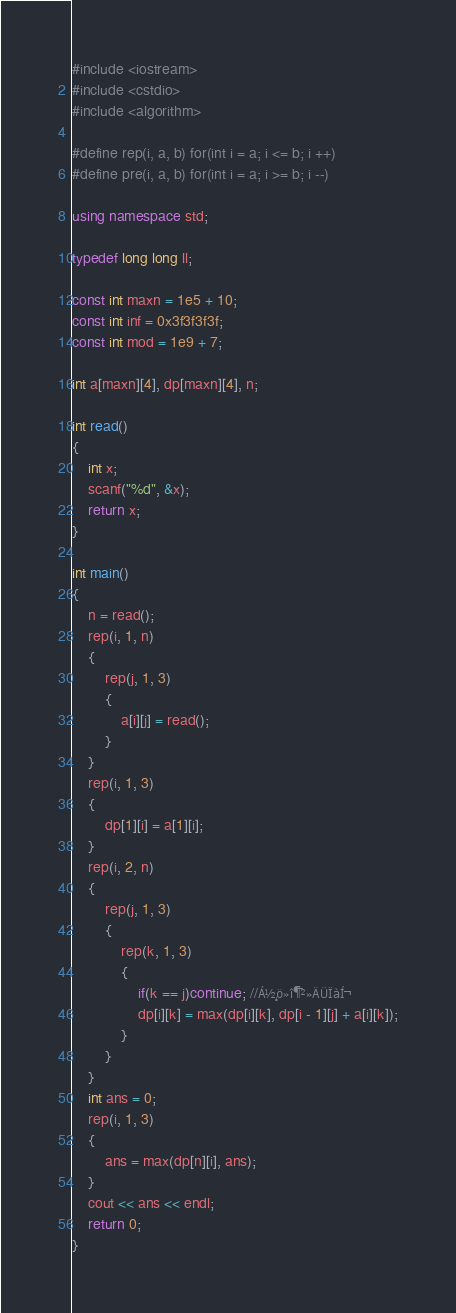<code> <loc_0><loc_0><loc_500><loc_500><_C++_>#include <iostream>
#include <cstdio>
#include <algorithm>

#define rep(i, a, b) for(int i = a; i <= b; i ++)
#define pre(i, a, b) for(int i = a; i >= b; i --)

using namespace std;

typedef long long ll;

const int maxn = 1e5 + 10;
const int inf = 0x3f3f3f3f;
const int mod = 1e9 + 7;

int a[maxn][4], dp[maxn][4], n;

int read()
{
	int x;
	scanf("%d", &x);
	return x;
}

int main()
{
	n = read();
	rep(i, 1, n)
	{
		rep(j, 1, 3)
		{
			a[i][j] = read();
		}
	}
	rep(i, 1, 3)
	{
		dp[1][i] = a[1][i];
	}
	rep(i, 2, n)
	{
		rep(j, 1, 3)
		{
			rep(k, 1, 3)
			{
				if(k == j)continue; //Á½¸ö»î¶¯²»ÄÜÏàÍ¬ 
				dp[i][k] = max(dp[i][k], dp[i - 1][j] + a[i][k]);
			}
		}
	}
	int ans = 0;
	rep(i, 1, 3)
	{
		ans = max(dp[n][i], ans);
	}
	cout << ans << endl;
	return 0;
}</code> 